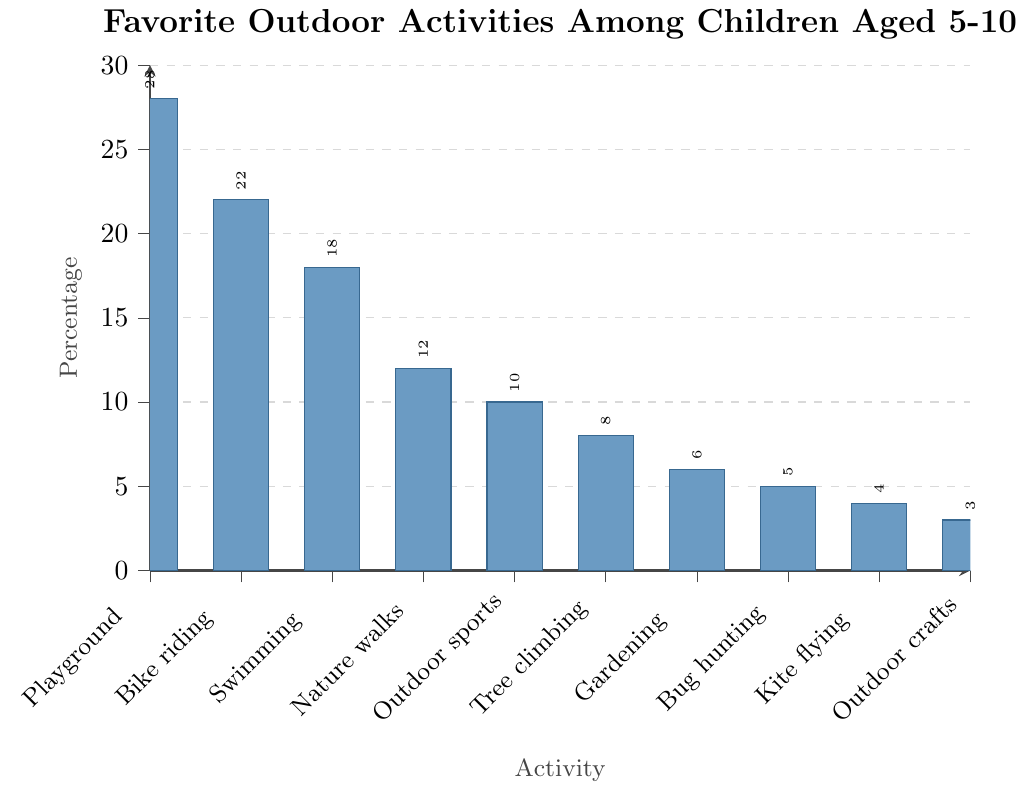Which activity is the most popular among children aged 5-10? The highest bar in the chart represents the most popular activity. This bar corresponds to the Playground activity with a 28% preference.
Answer: Playground Which two activities have the closest percentages? Looking at the heights of the bars, Bug hunting and Kite flying have very close percentages, with Bug hunting at 5% and Kite flying at 4%, showing a 1% difference.
Answer: Bug hunting and Kite flying What is the total percentage of children who prefer Playground, Bike riding, and Swimming? Add the percentages for Playground (28%), Bike riding (22%), and Swimming (18%). The total is 28 + 22 + 18 = 68%.
Answer: 68% By how much does the percentage of children who prefer Nature walks exceed those who prefer Kite flying? Subtract the percentage of Kite flying (4%) from Nature walks (12%). The difference is 12 - 4 = 8%.
Answer: 8% Are more children interested in Outdoor sports or Tree climbing? Compare the heights of the bars for Outdoor sports and Tree climbing. Outdoor sports has 10%, while Tree climbing has 8%, so more children are interested in Outdoor sports.
Answer: Outdoor sports What is the average percentage for the least three preferred activities? The least three preferred activities are Kite flying (4%), Outdoor crafts (3%), and Bug hunting (5%). The average is (4 + 3 + 5) / 3 = 12 / 3 = 4%.
Answer: 4% Which activities have a percentage less than 10%? Identify the bars shorter than the 10% mark. These activities are Tree climbing (8%), Gardening (6%), Bug hunting (5%), Kite flying (4%), and Outdoor crafts (3%).
Answer: Tree climbing, Gardening, Bug hunting, Kite flying, Outdoor crafts What is the difference between the percentages of the most and least popular activities? Subtract the percentage of the least popular activity (Outdoor crafts at 3%) from the most popular activity (Playground at 28%). The difference is 28 - 3 = 25%.
Answer: 25% Which activity has a percentage that is exactly double that of Bug hunting? Bug hunting has a 5% preference. An activity with double this percentage has 5 * 2 = 10%, which corresponds to Outdoor sports.
Answer: Outdoor sports How many activities have a preference percentage greater than 15%? Count the bars that exceed the 15% mark. These are Playground (28%), Bike riding (22%), and Swimming (18%), making a total of three activities.
Answer: 3 